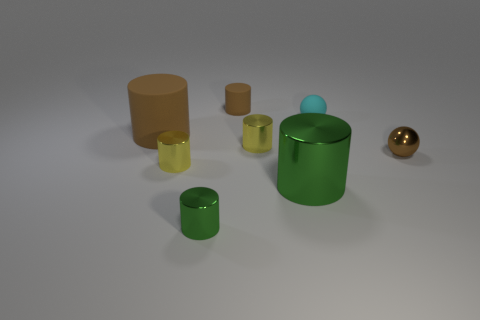What number of things are purple objects or tiny brown shiny balls?
Provide a short and direct response. 1. What color is the matte sphere?
Your response must be concise. Cyan. How many other objects are the same color as the small rubber sphere?
Keep it short and to the point. 0. Are there any green metal things on the right side of the large matte thing?
Offer a terse response. Yes. What color is the small rubber thing left of the tiny shiny cylinder that is behind the tiny brown thing in front of the large brown object?
Provide a short and direct response. Brown. What number of metal cylinders are both in front of the brown sphere and to the left of the large shiny thing?
Make the answer very short. 2. How many cylinders are small yellow shiny things or brown objects?
Your response must be concise. 4. Are any green metallic cylinders visible?
Make the answer very short. Yes. How many other objects are there of the same material as the large green cylinder?
Offer a very short reply. 4. There is a brown cylinder that is the same size as the matte ball; what material is it?
Offer a very short reply. Rubber. 